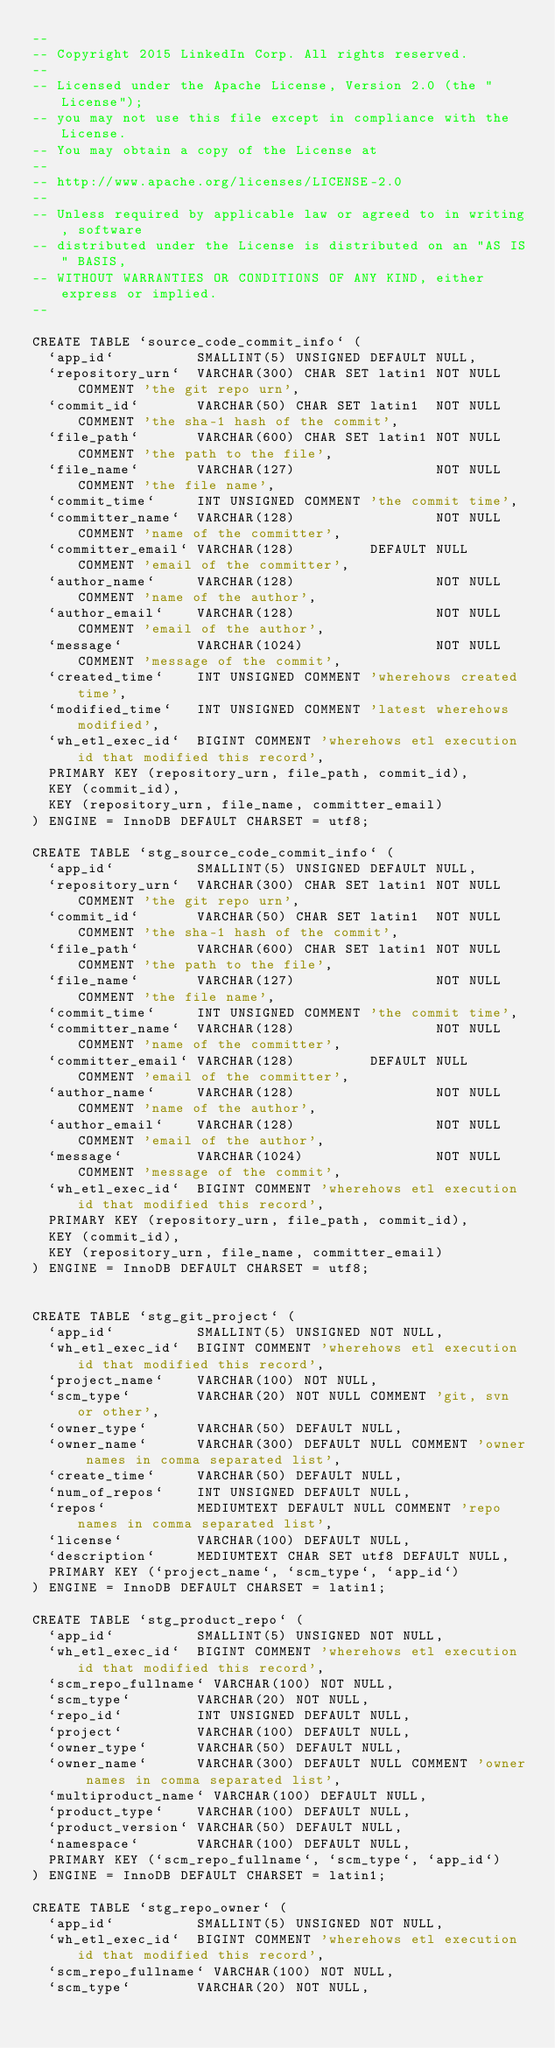<code> <loc_0><loc_0><loc_500><loc_500><_SQL_>--
-- Copyright 2015 LinkedIn Corp. All rights reserved.
--
-- Licensed under the Apache License, Version 2.0 (the "License");
-- you may not use this file except in compliance with the License.
-- You may obtain a copy of the License at
--
-- http://www.apache.org/licenses/LICENSE-2.0
--
-- Unless required by applicable law or agreed to in writing, software
-- distributed under the License is distributed on an "AS IS" BASIS,
-- WITHOUT WARRANTIES OR CONDITIONS OF ANY KIND, either express or implied.
--

CREATE TABLE `source_code_commit_info` (
  `app_id`          SMALLINT(5) UNSIGNED DEFAULT NULL,
  `repository_urn`  VARCHAR(300) CHAR SET latin1 NOT NULL COMMENT 'the git repo urn',
  `commit_id`       VARCHAR(50) CHAR SET latin1  NOT NULL COMMENT 'the sha-1 hash of the commit',
  `file_path`       VARCHAR(600) CHAR SET latin1 NOT NULL COMMENT 'the path to the file',
  `file_name`       VARCHAR(127)                 NOT NULL COMMENT 'the file name',
  `commit_time`     INT UNSIGNED COMMENT 'the commit time',
  `committer_name`  VARCHAR(128)                 NOT NULL COMMENT 'name of the committer',
  `committer_email` VARCHAR(128)         DEFAULT NULL COMMENT 'email of the committer',
  `author_name`     VARCHAR(128)                 NOT NULL COMMENT 'name of the author',
  `author_email`    VARCHAR(128)                 NOT NULL COMMENT 'email of the author',
  `message`         VARCHAR(1024)                NOT NULL COMMENT 'message of the commit',
  `created_time`    INT UNSIGNED COMMENT 'wherehows created time',
  `modified_time`   INT UNSIGNED COMMENT 'latest wherehows modified',
  `wh_etl_exec_id`  BIGINT COMMENT 'wherehows etl execution id that modified this record',
  PRIMARY KEY (repository_urn, file_path, commit_id),
  KEY (commit_id),
  KEY (repository_urn, file_name, committer_email)
) ENGINE = InnoDB DEFAULT CHARSET = utf8;

CREATE TABLE `stg_source_code_commit_info` (
  `app_id`          SMALLINT(5) UNSIGNED DEFAULT NULL,
  `repository_urn`  VARCHAR(300) CHAR SET latin1 NOT NULL COMMENT 'the git repo urn',
  `commit_id`       VARCHAR(50) CHAR SET latin1  NOT NULL COMMENT 'the sha-1 hash of the commit',
  `file_path`       VARCHAR(600) CHAR SET latin1 NOT NULL COMMENT 'the path to the file',
  `file_name`       VARCHAR(127)                 NOT NULL COMMENT 'the file name',
  `commit_time`     INT UNSIGNED COMMENT 'the commit time',
  `committer_name`  VARCHAR(128)                 NOT NULL COMMENT 'name of the committer',
  `committer_email` VARCHAR(128)         DEFAULT NULL COMMENT 'email of the committer',
  `author_name`     VARCHAR(128)                 NOT NULL COMMENT 'name of the author',
  `author_email`    VARCHAR(128)                 NOT NULL COMMENT 'email of the author',
  `message`         VARCHAR(1024)                NOT NULL COMMENT 'message of the commit',
  `wh_etl_exec_id`  BIGINT COMMENT 'wherehows etl execution id that modified this record',
  PRIMARY KEY (repository_urn, file_path, commit_id),
  KEY (commit_id),
  KEY (repository_urn, file_name, committer_email)
) ENGINE = InnoDB DEFAULT CHARSET = utf8;


CREATE TABLE `stg_git_project` (
  `app_id`          SMALLINT(5) UNSIGNED NOT NULL,
  `wh_etl_exec_id`  BIGINT COMMENT 'wherehows etl execution id that modified this record',
  `project_name`    VARCHAR(100) NOT NULL,
  `scm_type`        VARCHAR(20) NOT NULL COMMENT 'git, svn or other',
  `owner_type`      VARCHAR(50) DEFAULT NULL,
  `owner_name`      VARCHAR(300) DEFAULT NULL COMMENT 'owner names in comma separated list',
  `create_time`     VARCHAR(50) DEFAULT NULL,
  `num_of_repos`    INT UNSIGNED DEFAULT NULL,
  `repos`           MEDIUMTEXT DEFAULT NULL COMMENT 'repo names in comma separated list',
  `license`         VARCHAR(100) DEFAULT NULL,
  `description`     MEDIUMTEXT CHAR SET utf8 DEFAULT NULL,
  PRIMARY KEY (`project_name`, `scm_type`, `app_id`)
) ENGINE = InnoDB DEFAULT CHARSET = latin1;

CREATE TABLE `stg_product_repo` (
  `app_id`          SMALLINT(5) UNSIGNED NOT NULL,
  `wh_etl_exec_id`  BIGINT COMMENT 'wherehows etl execution id that modified this record',
  `scm_repo_fullname` VARCHAR(100) NOT NULL,
  `scm_type`        VARCHAR(20) NOT NULL,
  `repo_id`         INT UNSIGNED DEFAULT NULL,
  `project`         VARCHAR(100) DEFAULT NULL,
  `owner_type`      VARCHAR(50) DEFAULT NULL,
  `owner_name`      VARCHAR(300) DEFAULT NULL COMMENT 'owner names in comma separated list',
  `multiproduct_name` VARCHAR(100) DEFAULT NULL,
  `product_type`    VARCHAR(100) DEFAULT NULL,
  `product_version` VARCHAR(50) DEFAULT NULL,
  `namespace`       VARCHAR(100) DEFAULT NULL,
  PRIMARY KEY (`scm_repo_fullname`, `scm_type`, `app_id`)
) ENGINE = InnoDB DEFAULT CHARSET = latin1;

CREATE TABLE `stg_repo_owner` (
  `app_id`          SMALLINT(5) UNSIGNED NOT NULL,
  `wh_etl_exec_id`  BIGINT COMMENT 'wherehows etl execution id that modified this record',
  `scm_repo_fullname` VARCHAR(100) NOT NULL,
  `scm_type`        VARCHAR(20) NOT NULL,</code> 